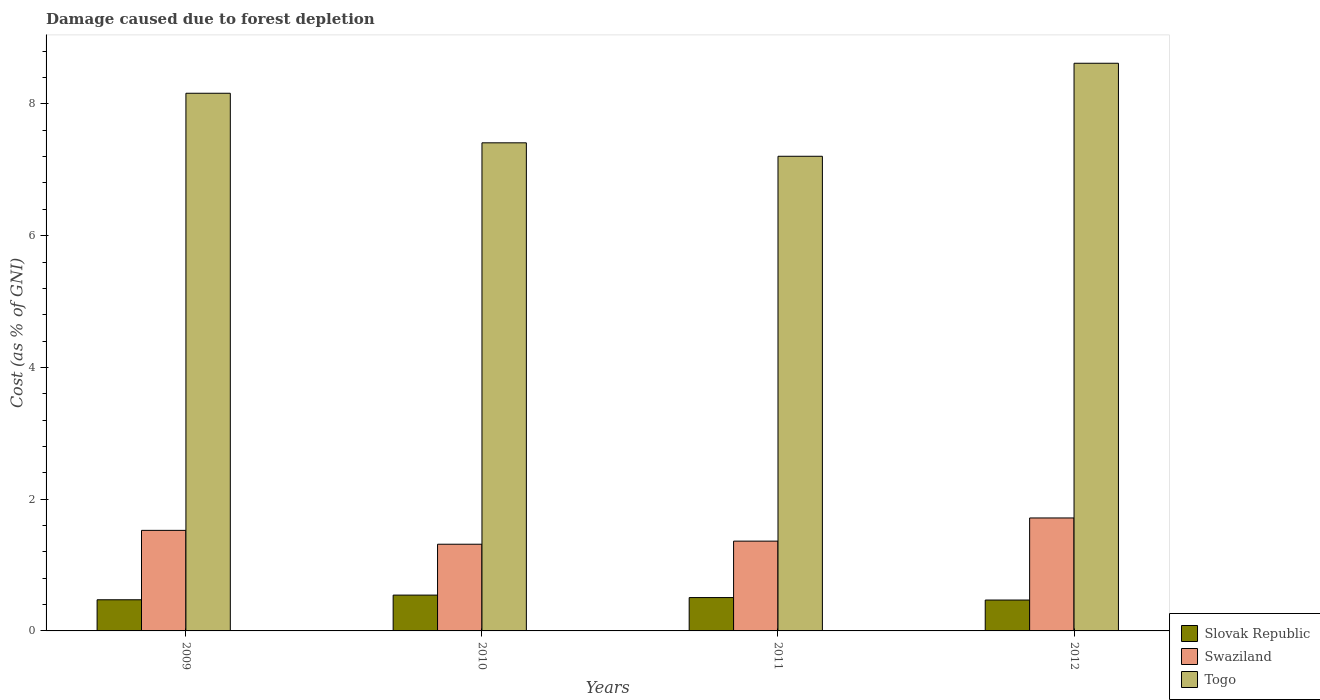How many groups of bars are there?
Ensure brevity in your answer.  4. Are the number of bars per tick equal to the number of legend labels?
Give a very brief answer. Yes. How many bars are there on the 4th tick from the right?
Make the answer very short. 3. What is the label of the 1st group of bars from the left?
Make the answer very short. 2009. In how many cases, is the number of bars for a given year not equal to the number of legend labels?
Your answer should be very brief. 0. What is the cost of damage caused due to forest depletion in Swaziland in 2011?
Your response must be concise. 1.36. Across all years, what is the maximum cost of damage caused due to forest depletion in Togo?
Keep it short and to the point. 8.62. Across all years, what is the minimum cost of damage caused due to forest depletion in Togo?
Make the answer very short. 7.21. In which year was the cost of damage caused due to forest depletion in Slovak Republic maximum?
Give a very brief answer. 2010. In which year was the cost of damage caused due to forest depletion in Slovak Republic minimum?
Your answer should be very brief. 2012. What is the total cost of damage caused due to forest depletion in Togo in the graph?
Offer a very short reply. 31.39. What is the difference between the cost of damage caused due to forest depletion in Togo in 2010 and that in 2011?
Provide a succinct answer. 0.2. What is the difference between the cost of damage caused due to forest depletion in Swaziland in 2011 and the cost of damage caused due to forest depletion in Togo in 2009?
Your answer should be very brief. -6.8. What is the average cost of damage caused due to forest depletion in Swaziland per year?
Provide a short and direct response. 1.48. In the year 2010, what is the difference between the cost of damage caused due to forest depletion in Swaziland and cost of damage caused due to forest depletion in Togo?
Your answer should be very brief. -6.09. In how many years, is the cost of damage caused due to forest depletion in Swaziland greater than 8 %?
Your response must be concise. 0. What is the ratio of the cost of damage caused due to forest depletion in Togo in 2009 to that in 2012?
Offer a very short reply. 0.95. Is the cost of damage caused due to forest depletion in Slovak Republic in 2009 less than that in 2012?
Your response must be concise. No. What is the difference between the highest and the second highest cost of damage caused due to forest depletion in Swaziland?
Provide a short and direct response. 0.19. What is the difference between the highest and the lowest cost of damage caused due to forest depletion in Slovak Republic?
Your answer should be compact. 0.07. In how many years, is the cost of damage caused due to forest depletion in Slovak Republic greater than the average cost of damage caused due to forest depletion in Slovak Republic taken over all years?
Offer a very short reply. 2. What does the 1st bar from the left in 2012 represents?
Provide a succinct answer. Slovak Republic. What does the 3rd bar from the right in 2009 represents?
Give a very brief answer. Slovak Republic. Is it the case that in every year, the sum of the cost of damage caused due to forest depletion in Togo and cost of damage caused due to forest depletion in Swaziland is greater than the cost of damage caused due to forest depletion in Slovak Republic?
Your response must be concise. Yes. How many years are there in the graph?
Offer a terse response. 4. What is the difference between two consecutive major ticks on the Y-axis?
Your response must be concise. 2. Does the graph contain any zero values?
Ensure brevity in your answer.  No. Where does the legend appear in the graph?
Keep it short and to the point. Bottom right. How are the legend labels stacked?
Offer a terse response. Vertical. What is the title of the graph?
Offer a terse response. Damage caused due to forest depletion. Does "Channel Islands" appear as one of the legend labels in the graph?
Keep it short and to the point. No. What is the label or title of the X-axis?
Offer a terse response. Years. What is the label or title of the Y-axis?
Keep it short and to the point. Cost (as % of GNI). What is the Cost (as % of GNI) of Slovak Republic in 2009?
Offer a terse response. 0.47. What is the Cost (as % of GNI) in Swaziland in 2009?
Your answer should be compact. 1.53. What is the Cost (as % of GNI) of Togo in 2009?
Give a very brief answer. 8.16. What is the Cost (as % of GNI) of Slovak Republic in 2010?
Offer a very short reply. 0.54. What is the Cost (as % of GNI) of Swaziland in 2010?
Your answer should be compact. 1.32. What is the Cost (as % of GNI) of Togo in 2010?
Keep it short and to the point. 7.41. What is the Cost (as % of GNI) in Slovak Republic in 2011?
Your answer should be very brief. 0.51. What is the Cost (as % of GNI) of Swaziland in 2011?
Give a very brief answer. 1.36. What is the Cost (as % of GNI) in Togo in 2011?
Offer a very short reply. 7.21. What is the Cost (as % of GNI) of Slovak Republic in 2012?
Provide a short and direct response. 0.47. What is the Cost (as % of GNI) of Swaziland in 2012?
Provide a short and direct response. 1.71. What is the Cost (as % of GNI) in Togo in 2012?
Your answer should be very brief. 8.62. Across all years, what is the maximum Cost (as % of GNI) in Slovak Republic?
Keep it short and to the point. 0.54. Across all years, what is the maximum Cost (as % of GNI) in Swaziland?
Offer a terse response. 1.71. Across all years, what is the maximum Cost (as % of GNI) of Togo?
Keep it short and to the point. 8.62. Across all years, what is the minimum Cost (as % of GNI) in Slovak Republic?
Make the answer very short. 0.47. Across all years, what is the minimum Cost (as % of GNI) in Swaziland?
Offer a terse response. 1.32. Across all years, what is the minimum Cost (as % of GNI) of Togo?
Make the answer very short. 7.21. What is the total Cost (as % of GNI) in Slovak Republic in the graph?
Your answer should be compact. 1.99. What is the total Cost (as % of GNI) in Swaziland in the graph?
Offer a terse response. 5.92. What is the total Cost (as % of GNI) in Togo in the graph?
Give a very brief answer. 31.39. What is the difference between the Cost (as % of GNI) of Slovak Republic in 2009 and that in 2010?
Offer a terse response. -0.07. What is the difference between the Cost (as % of GNI) in Swaziland in 2009 and that in 2010?
Provide a succinct answer. 0.21. What is the difference between the Cost (as % of GNI) in Togo in 2009 and that in 2010?
Your response must be concise. 0.75. What is the difference between the Cost (as % of GNI) of Slovak Republic in 2009 and that in 2011?
Your answer should be very brief. -0.03. What is the difference between the Cost (as % of GNI) in Swaziland in 2009 and that in 2011?
Your response must be concise. 0.16. What is the difference between the Cost (as % of GNI) in Togo in 2009 and that in 2011?
Provide a short and direct response. 0.96. What is the difference between the Cost (as % of GNI) in Slovak Republic in 2009 and that in 2012?
Ensure brevity in your answer.  0. What is the difference between the Cost (as % of GNI) of Swaziland in 2009 and that in 2012?
Your answer should be very brief. -0.19. What is the difference between the Cost (as % of GNI) in Togo in 2009 and that in 2012?
Provide a succinct answer. -0.46. What is the difference between the Cost (as % of GNI) of Slovak Republic in 2010 and that in 2011?
Ensure brevity in your answer.  0.04. What is the difference between the Cost (as % of GNI) in Swaziland in 2010 and that in 2011?
Your response must be concise. -0.05. What is the difference between the Cost (as % of GNI) of Togo in 2010 and that in 2011?
Keep it short and to the point. 0.2. What is the difference between the Cost (as % of GNI) of Slovak Republic in 2010 and that in 2012?
Your answer should be compact. 0.07. What is the difference between the Cost (as % of GNI) of Swaziland in 2010 and that in 2012?
Make the answer very short. -0.4. What is the difference between the Cost (as % of GNI) in Togo in 2010 and that in 2012?
Provide a succinct answer. -1.21. What is the difference between the Cost (as % of GNI) of Slovak Republic in 2011 and that in 2012?
Your response must be concise. 0.04. What is the difference between the Cost (as % of GNI) in Swaziland in 2011 and that in 2012?
Make the answer very short. -0.35. What is the difference between the Cost (as % of GNI) of Togo in 2011 and that in 2012?
Offer a terse response. -1.41. What is the difference between the Cost (as % of GNI) of Slovak Republic in 2009 and the Cost (as % of GNI) of Swaziland in 2010?
Make the answer very short. -0.84. What is the difference between the Cost (as % of GNI) of Slovak Republic in 2009 and the Cost (as % of GNI) of Togo in 2010?
Offer a terse response. -6.94. What is the difference between the Cost (as % of GNI) of Swaziland in 2009 and the Cost (as % of GNI) of Togo in 2010?
Offer a terse response. -5.88. What is the difference between the Cost (as % of GNI) in Slovak Republic in 2009 and the Cost (as % of GNI) in Swaziland in 2011?
Make the answer very short. -0.89. What is the difference between the Cost (as % of GNI) of Slovak Republic in 2009 and the Cost (as % of GNI) of Togo in 2011?
Your answer should be very brief. -6.73. What is the difference between the Cost (as % of GNI) of Swaziland in 2009 and the Cost (as % of GNI) of Togo in 2011?
Your answer should be compact. -5.68. What is the difference between the Cost (as % of GNI) in Slovak Republic in 2009 and the Cost (as % of GNI) in Swaziland in 2012?
Keep it short and to the point. -1.24. What is the difference between the Cost (as % of GNI) in Slovak Republic in 2009 and the Cost (as % of GNI) in Togo in 2012?
Provide a short and direct response. -8.14. What is the difference between the Cost (as % of GNI) of Swaziland in 2009 and the Cost (as % of GNI) of Togo in 2012?
Ensure brevity in your answer.  -7.09. What is the difference between the Cost (as % of GNI) of Slovak Republic in 2010 and the Cost (as % of GNI) of Swaziland in 2011?
Provide a short and direct response. -0.82. What is the difference between the Cost (as % of GNI) of Slovak Republic in 2010 and the Cost (as % of GNI) of Togo in 2011?
Provide a short and direct response. -6.66. What is the difference between the Cost (as % of GNI) in Swaziland in 2010 and the Cost (as % of GNI) in Togo in 2011?
Your answer should be compact. -5.89. What is the difference between the Cost (as % of GNI) of Slovak Republic in 2010 and the Cost (as % of GNI) of Swaziland in 2012?
Ensure brevity in your answer.  -1.17. What is the difference between the Cost (as % of GNI) of Slovak Republic in 2010 and the Cost (as % of GNI) of Togo in 2012?
Give a very brief answer. -8.07. What is the difference between the Cost (as % of GNI) of Swaziland in 2010 and the Cost (as % of GNI) of Togo in 2012?
Offer a very short reply. -7.3. What is the difference between the Cost (as % of GNI) of Slovak Republic in 2011 and the Cost (as % of GNI) of Swaziland in 2012?
Provide a succinct answer. -1.21. What is the difference between the Cost (as % of GNI) of Slovak Republic in 2011 and the Cost (as % of GNI) of Togo in 2012?
Ensure brevity in your answer.  -8.11. What is the difference between the Cost (as % of GNI) of Swaziland in 2011 and the Cost (as % of GNI) of Togo in 2012?
Make the answer very short. -7.25. What is the average Cost (as % of GNI) in Slovak Republic per year?
Your answer should be very brief. 0.5. What is the average Cost (as % of GNI) of Swaziland per year?
Your answer should be very brief. 1.48. What is the average Cost (as % of GNI) in Togo per year?
Provide a succinct answer. 7.85. In the year 2009, what is the difference between the Cost (as % of GNI) in Slovak Republic and Cost (as % of GNI) in Swaziland?
Offer a very short reply. -1.05. In the year 2009, what is the difference between the Cost (as % of GNI) in Slovak Republic and Cost (as % of GNI) in Togo?
Provide a short and direct response. -7.69. In the year 2009, what is the difference between the Cost (as % of GNI) in Swaziland and Cost (as % of GNI) in Togo?
Ensure brevity in your answer.  -6.64. In the year 2010, what is the difference between the Cost (as % of GNI) in Slovak Republic and Cost (as % of GNI) in Swaziland?
Keep it short and to the point. -0.77. In the year 2010, what is the difference between the Cost (as % of GNI) of Slovak Republic and Cost (as % of GNI) of Togo?
Give a very brief answer. -6.87. In the year 2010, what is the difference between the Cost (as % of GNI) in Swaziland and Cost (as % of GNI) in Togo?
Ensure brevity in your answer.  -6.09. In the year 2011, what is the difference between the Cost (as % of GNI) of Slovak Republic and Cost (as % of GNI) of Swaziland?
Your answer should be very brief. -0.86. In the year 2011, what is the difference between the Cost (as % of GNI) in Slovak Republic and Cost (as % of GNI) in Togo?
Make the answer very short. -6.7. In the year 2011, what is the difference between the Cost (as % of GNI) of Swaziland and Cost (as % of GNI) of Togo?
Keep it short and to the point. -5.84. In the year 2012, what is the difference between the Cost (as % of GNI) of Slovak Republic and Cost (as % of GNI) of Swaziland?
Offer a very short reply. -1.25. In the year 2012, what is the difference between the Cost (as % of GNI) of Slovak Republic and Cost (as % of GNI) of Togo?
Give a very brief answer. -8.15. In the year 2012, what is the difference between the Cost (as % of GNI) of Swaziland and Cost (as % of GNI) of Togo?
Offer a very short reply. -6.9. What is the ratio of the Cost (as % of GNI) of Slovak Republic in 2009 to that in 2010?
Provide a short and direct response. 0.87. What is the ratio of the Cost (as % of GNI) in Swaziland in 2009 to that in 2010?
Keep it short and to the point. 1.16. What is the ratio of the Cost (as % of GNI) in Togo in 2009 to that in 2010?
Offer a terse response. 1.1. What is the ratio of the Cost (as % of GNI) of Slovak Republic in 2009 to that in 2011?
Keep it short and to the point. 0.93. What is the ratio of the Cost (as % of GNI) in Swaziland in 2009 to that in 2011?
Your answer should be compact. 1.12. What is the ratio of the Cost (as % of GNI) of Togo in 2009 to that in 2011?
Make the answer very short. 1.13. What is the ratio of the Cost (as % of GNI) in Slovak Republic in 2009 to that in 2012?
Offer a very short reply. 1.01. What is the ratio of the Cost (as % of GNI) of Swaziland in 2009 to that in 2012?
Give a very brief answer. 0.89. What is the ratio of the Cost (as % of GNI) in Togo in 2009 to that in 2012?
Your response must be concise. 0.95. What is the ratio of the Cost (as % of GNI) of Slovak Republic in 2010 to that in 2011?
Your answer should be compact. 1.07. What is the ratio of the Cost (as % of GNI) in Swaziland in 2010 to that in 2011?
Offer a terse response. 0.97. What is the ratio of the Cost (as % of GNI) of Togo in 2010 to that in 2011?
Keep it short and to the point. 1.03. What is the ratio of the Cost (as % of GNI) of Slovak Republic in 2010 to that in 2012?
Give a very brief answer. 1.16. What is the ratio of the Cost (as % of GNI) of Swaziland in 2010 to that in 2012?
Provide a short and direct response. 0.77. What is the ratio of the Cost (as % of GNI) of Togo in 2010 to that in 2012?
Your answer should be compact. 0.86. What is the ratio of the Cost (as % of GNI) of Slovak Republic in 2011 to that in 2012?
Keep it short and to the point. 1.08. What is the ratio of the Cost (as % of GNI) of Swaziland in 2011 to that in 2012?
Provide a succinct answer. 0.79. What is the ratio of the Cost (as % of GNI) in Togo in 2011 to that in 2012?
Offer a very short reply. 0.84. What is the difference between the highest and the second highest Cost (as % of GNI) in Slovak Republic?
Offer a very short reply. 0.04. What is the difference between the highest and the second highest Cost (as % of GNI) in Swaziland?
Your answer should be compact. 0.19. What is the difference between the highest and the second highest Cost (as % of GNI) of Togo?
Offer a terse response. 0.46. What is the difference between the highest and the lowest Cost (as % of GNI) of Slovak Republic?
Offer a terse response. 0.07. What is the difference between the highest and the lowest Cost (as % of GNI) of Swaziland?
Make the answer very short. 0.4. What is the difference between the highest and the lowest Cost (as % of GNI) in Togo?
Your answer should be compact. 1.41. 